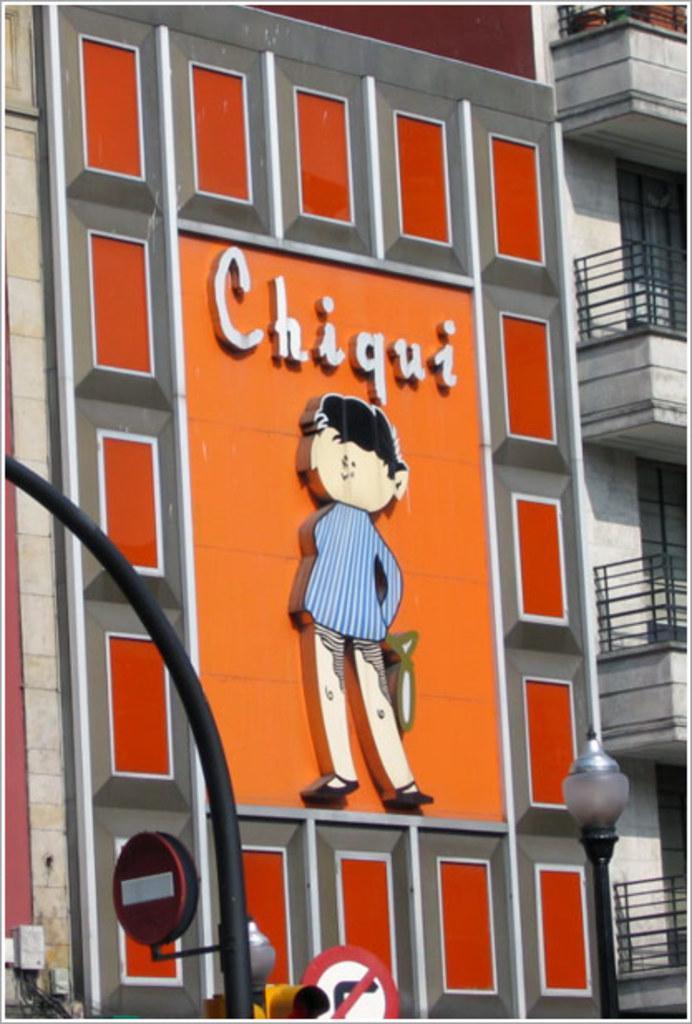Can you describe this image briefly? On the right side of the image there is a building with walls, windows and railings. And there is a building with designs, name and statue of a person. At the bottom of the image there are poles with sign boards and traffic signals. 